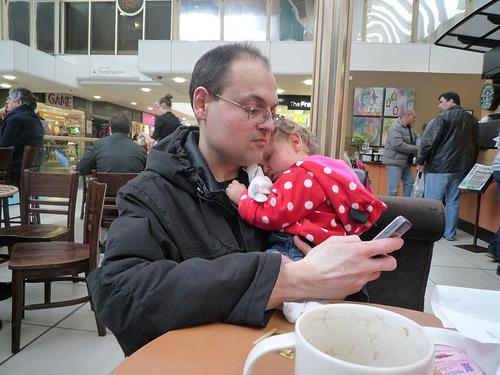Mention any noticeable features in the man's hand while holding the cellphone. Visible veins can be seen in the man's hand as he holds the cellphone. Mention a fashion detail about the man's jacket in the image. The man is wearing a black jacket with a hoodie that has black mouse ears on the hood. List two other objects found in the image, their color and position in the picture. There are brown wooden chairs near the table, and a large colorful painting on the wall behind the man and baby. How many men are standing at the mall, and what are they wearing? There are two men standing at the mall. One is wearing a leather jacket and blue jeans, while the other is wearing a gray jacket and blue jeans. Find the activity a man is engaged in with a specific item in his hand. A man is typing on his silver phone while holding it in his right hand. Provide details on the eyeglasses worn by the man in the scene. The man is wearing gray thin glasses on his face with rectangular lenses. Describe the state of the coffee mug and its position in relation to the nearest furniture. There is an empty coffee mug with a red stain inside it on a wooden table. Explain the scenario of a baby girl and the person holding her in the image. A man is holding a baby girl in his arms, with the baby girl wearing a red sweater with white dots and she is asleep on his chest. 